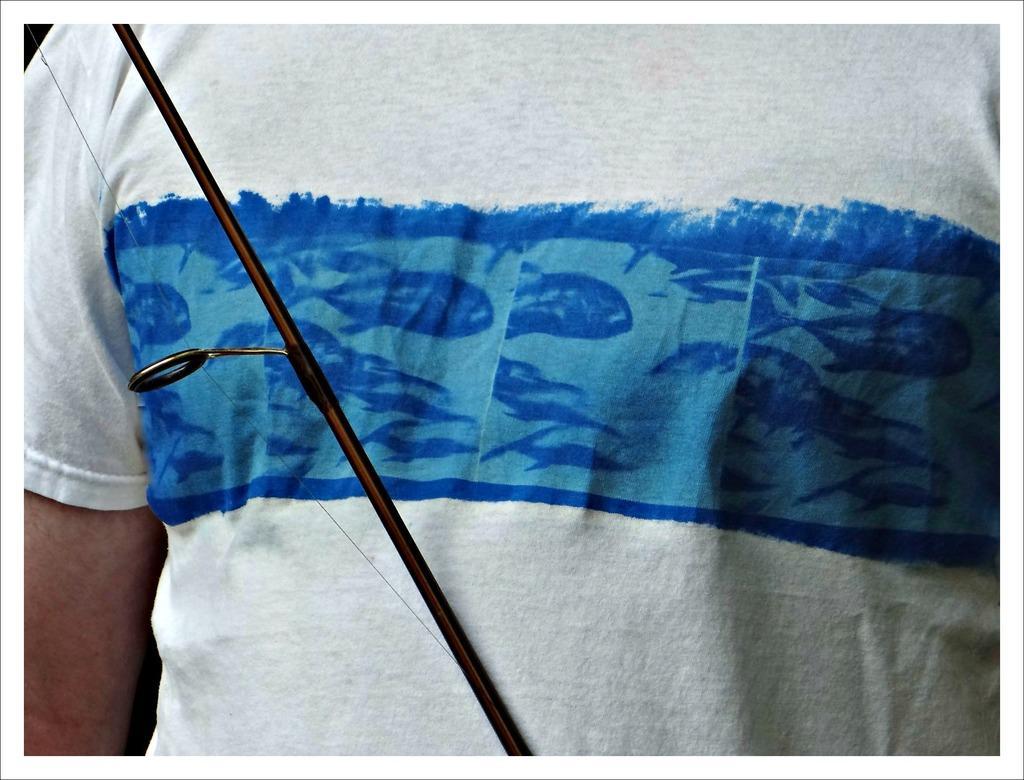In one or two sentences, can you explain what this image depicts? In this picture we can see one person with white and blue shirt. 